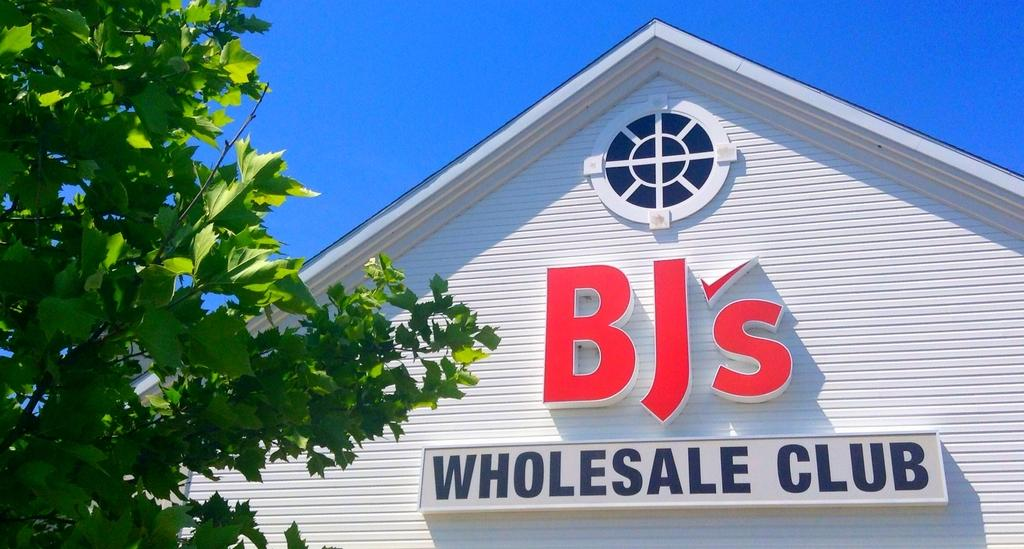<image>
Share a concise interpretation of the image provided. A sign for BJ's Wholesale Club against the peak of a white clapboard building. 